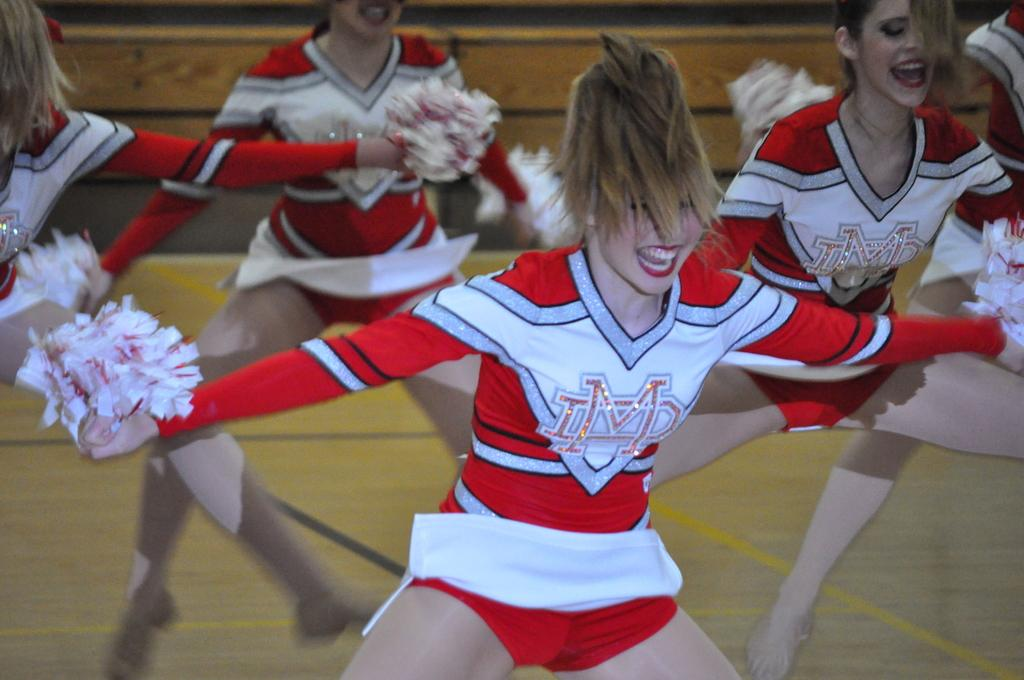<image>
Describe the image concisely. A group of cheerleaders depicting IMD logos on their uniforms as they perform. 